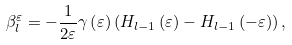<formula> <loc_0><loc_0><loc_500><loc_500>\beta _ { l } ^ { \varepsilon } = - \frac { 1 } { 2 \varepsilon } \gamma \left ( \varepsilon \right ) \left ( H _ { l - 1 } \left ( \varepsilon \right ) - H _ { l - 1 } \left ( - \varepsilon \right ) \right ) ,</formula> 